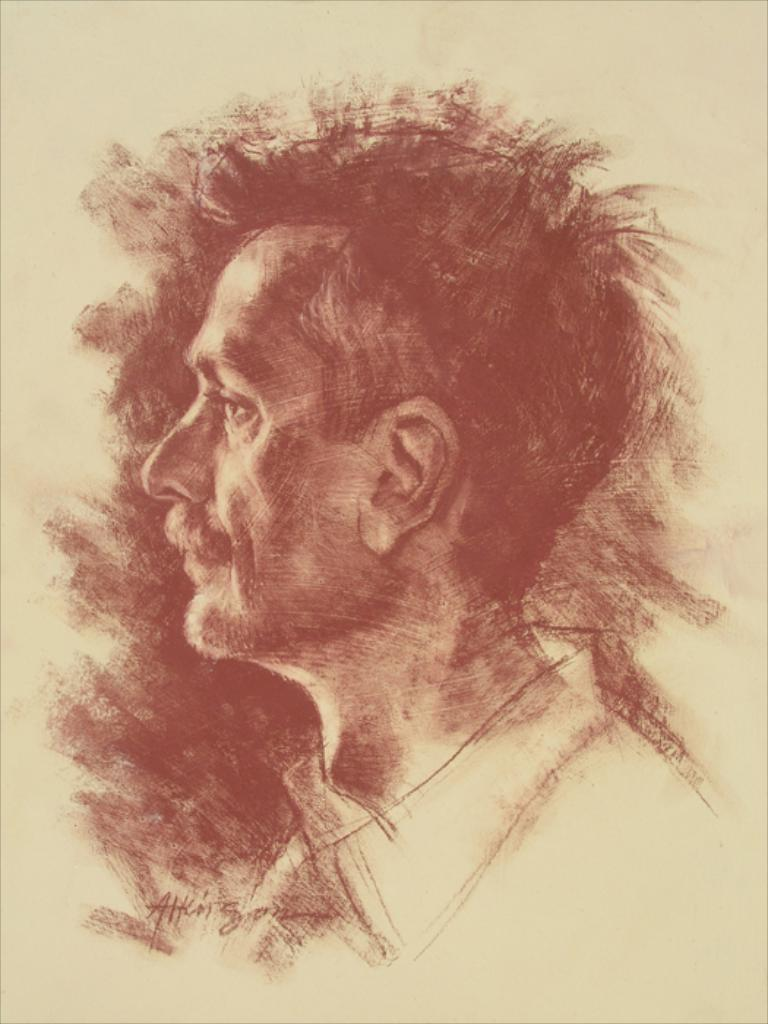What is depicted in the image? There is a drawing of a man in the image. Is the man in the drawing currently in jail? There is no information about the man's location or situation in the image, so it cannot be determined if he is in jail. 